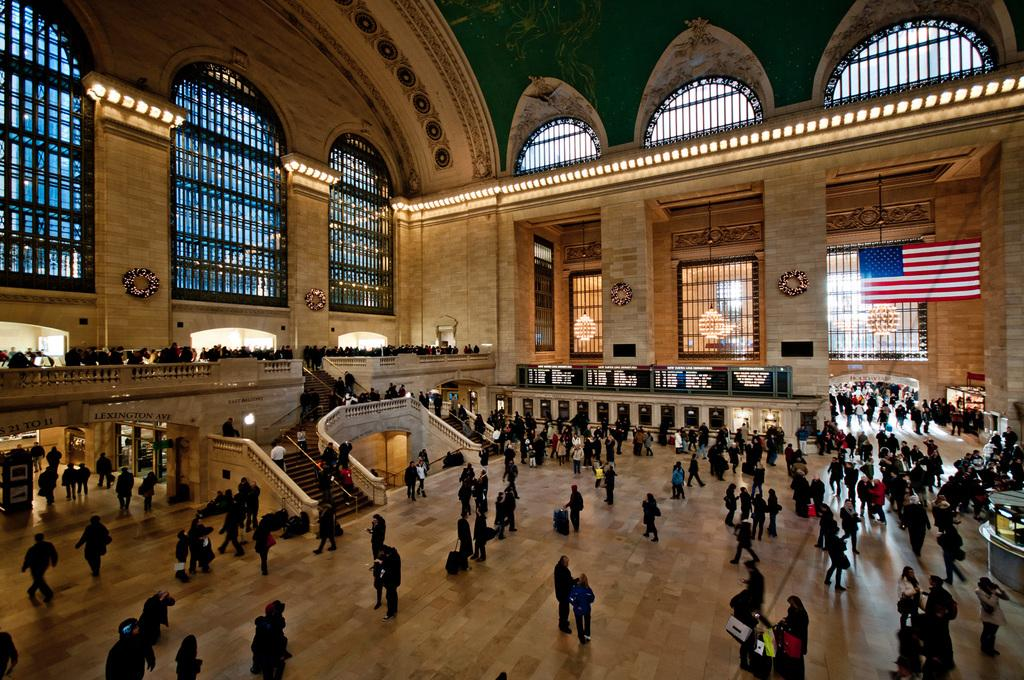What location is depicted in the image? The image depicts Grand Central Terminal. What are some of the people in the image doing? Some people in the image are standing, while others are walking. Can you describe what some people are carrying in the image? Some people in the image are holding bags in their hands. What type of flower can be seen in the image? There are no flowers present in the image. 